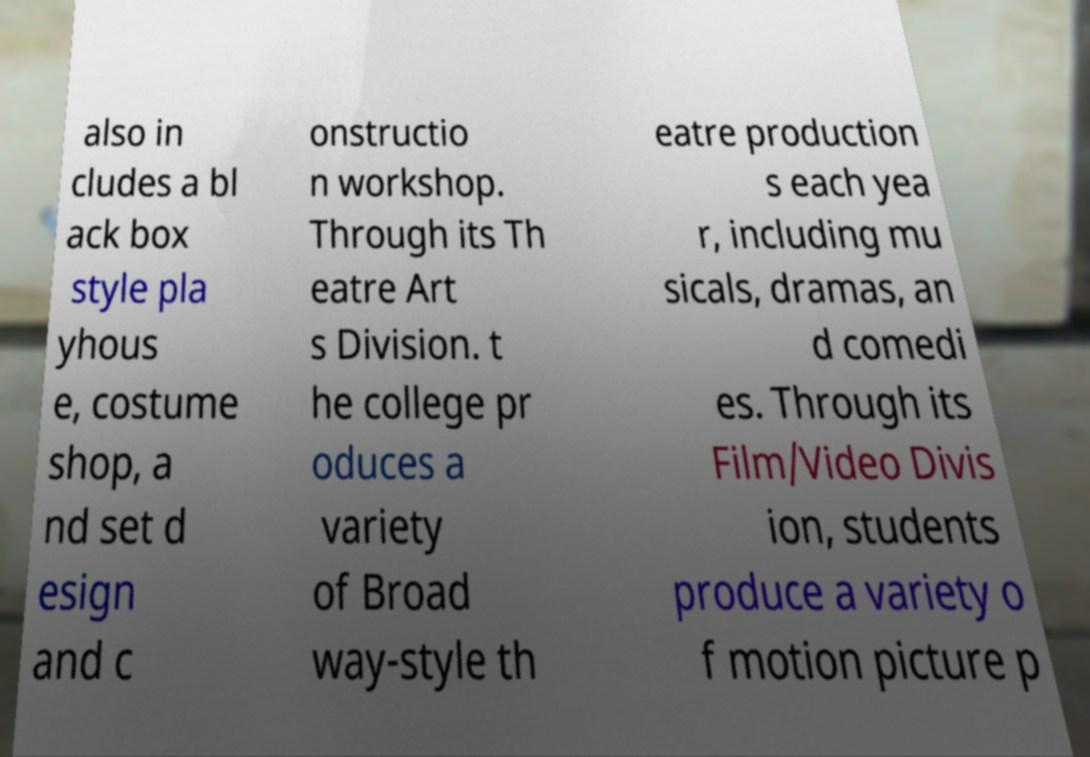Could you assist in decoding the text presented in this image and type it out clearly? also in cludes a bl ack box style pla yhous e, costume shop, a nd set d esign and c onstructio n workshop. Through its Th eatre Art s Division. t he college pr oduces a variety of Broad way-style th eatre production s each yea r, including mu sicals, dramas, an d comedi es. Through its Film/Video Divis ion, students produce a variety o f motion picture p 